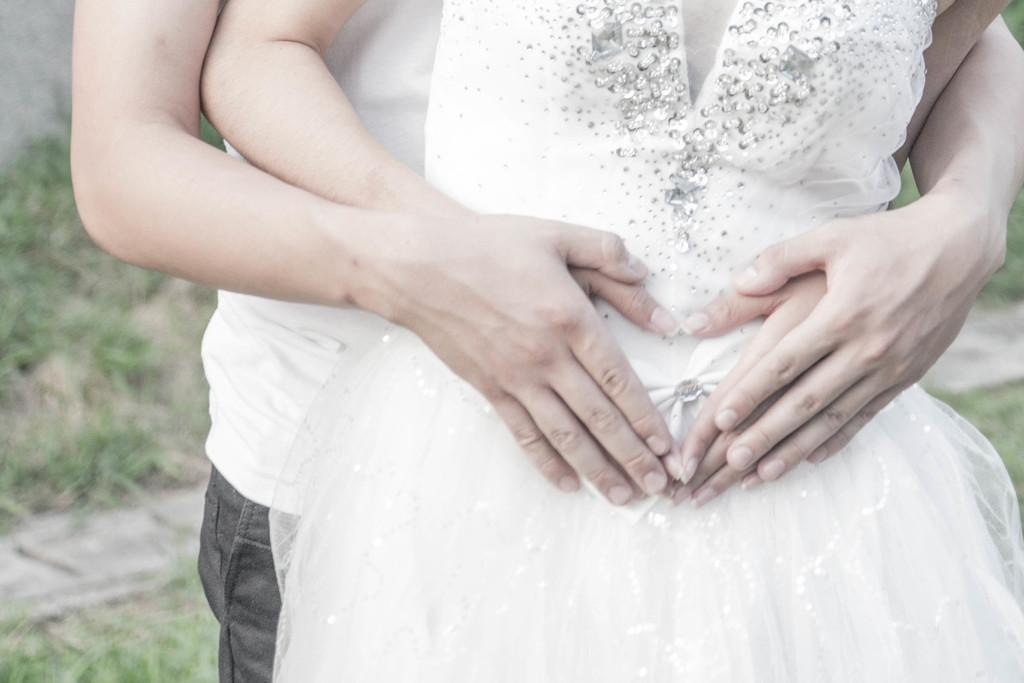Who are the people in the foreground of the image? There is a man and a woman in the foreground of the image. What is the setting of the image? The setting includes grass and a walkway in the background. How many islands can be seen in the image? There are no islands present in the image; it features a man, a woman, grass, and a walkway. 